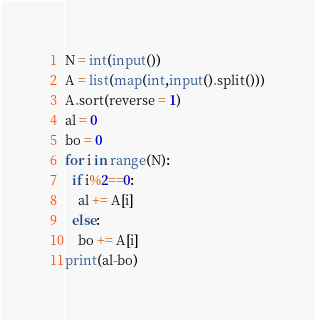<code> <loc_0><loc_0><loc_500><loc_500><_Python_>N = int(input())
A = list(map(int,input().split()))
A.sort(reverse = 1)
al = 0
bo = 0
for i in range(N):
  if i%2==0:
    al += A[i]
  else:
    bo += A[i]
print(al-bo)</code> 